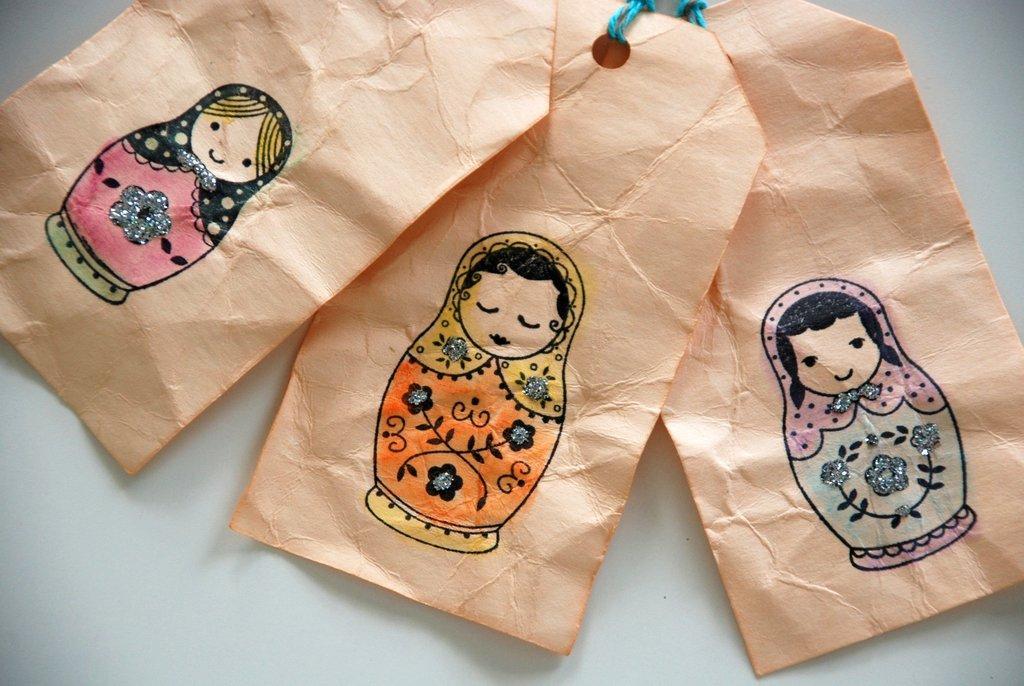How would you summarize this image in a sentence or two? In this image I see the white color surface on which there are 3 tags on which there is an art and I see the blue color threads over here. 